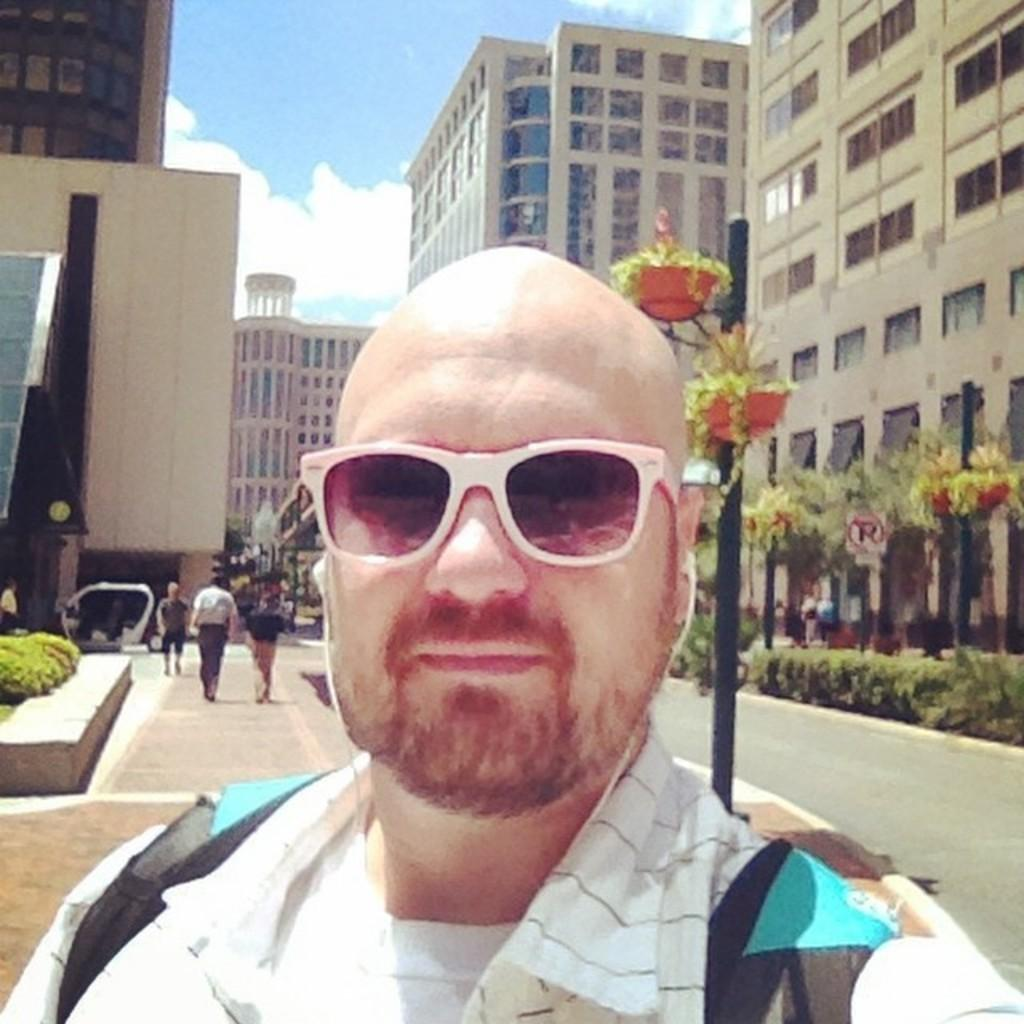What is the main subject of the image? A: There is a person standing on the road in the center of the image. Can you describe the surroundings of the person? In the background of the image, there are persons, buildings, poles, plants, and the sky visible. What is the condition of the sky in the image? The sky is visible in the background of the image, and there are clouds present. What type of tub can be seen in the image? There is no tub present in the image. What subject is being taught in the class depicted in the image? There is no class or any indication of a subject being taught in the image. 